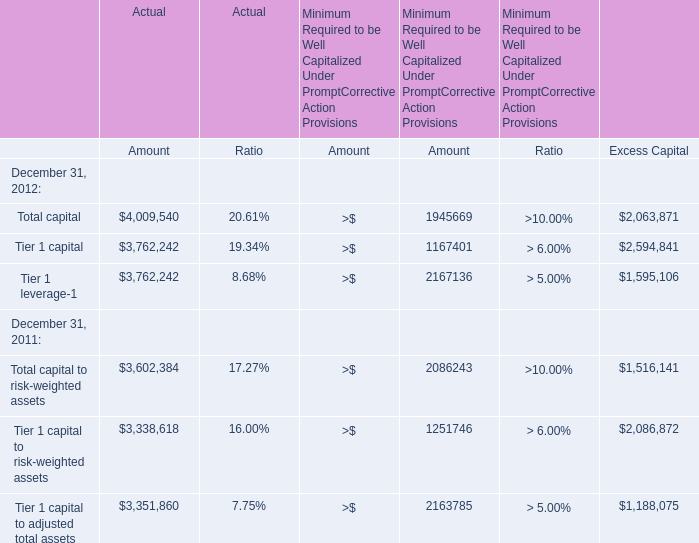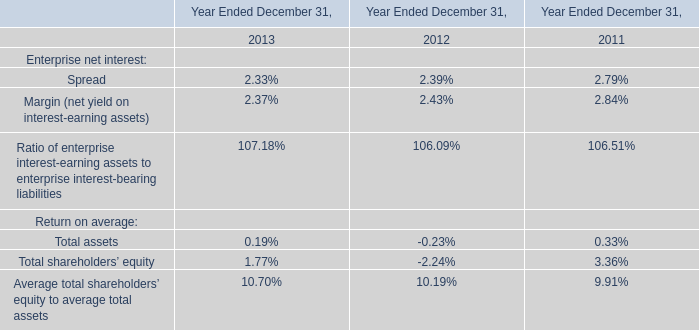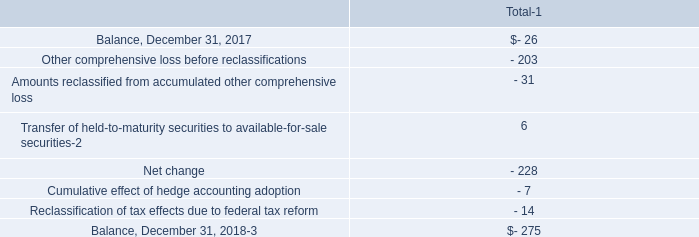What's the difference of Actual Total capital between 2012 and 2011? 
Computations: (4009540 - 3602384)
Answer: 407156.0. 